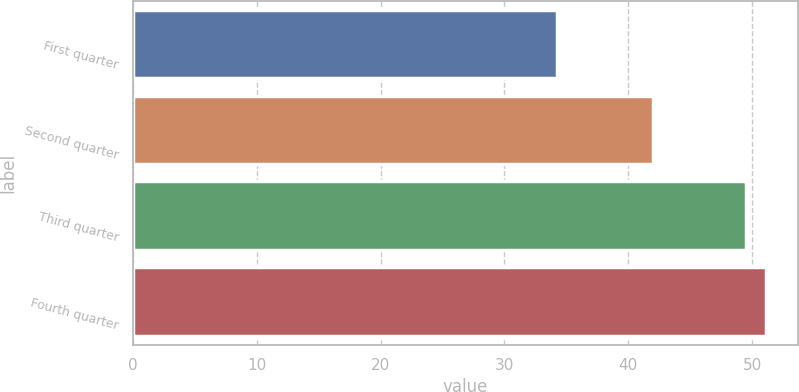Convert chart. <chart><loc_0><loc_0><loc_500><loc_500><bar_chart><fcel>First quarter<fcel>Second quarter<fcel>Third quarter<fcel>Fourth quarter<nl><fcel>34.25<fcel>42<fcel>49.5<fcel>51.14<nl></chart> 